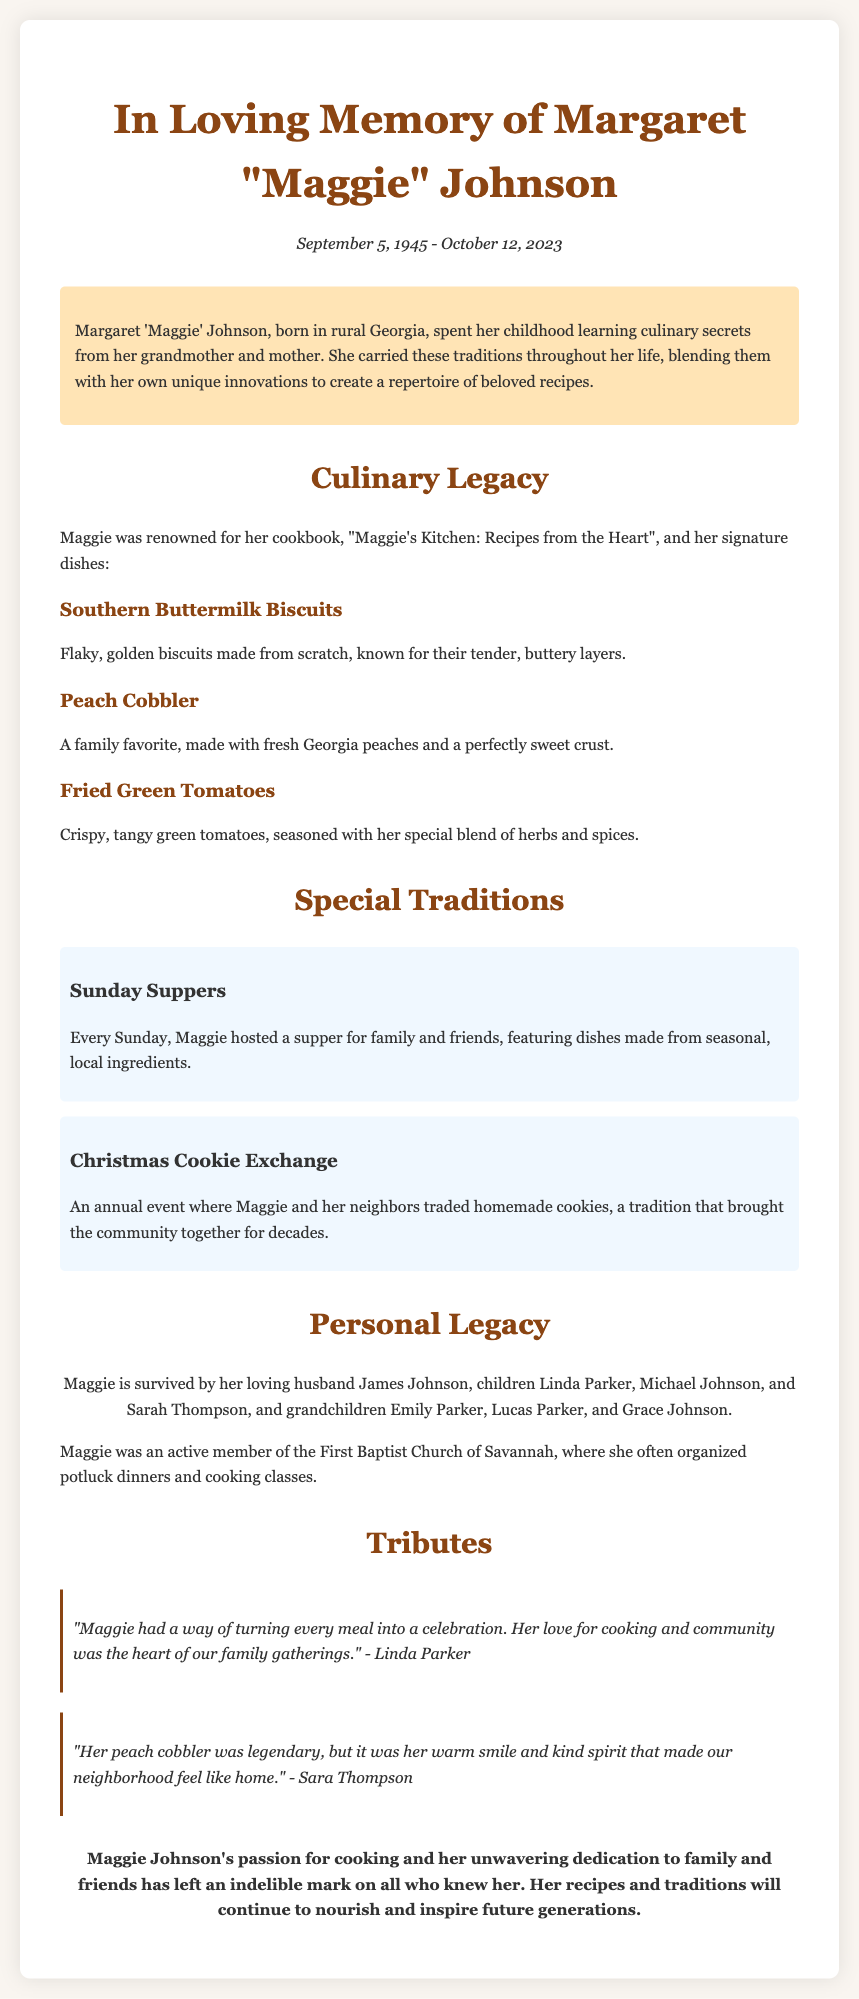What is the full name of the person being commemorated? The document mentions "Margaret 'Maggie' Johnson" as the person being remembered.
Answer: Margaret 'Maggie' Johnson What is the date of birth? The document states that Maggie was born on September 5, 1945.
Answer: September 5, 1945 What is the title of Maggie's cookbook? The document lists the cookbook as "Maggie's Kitchen: Recipes from the Heart".
Answer: Maggie's Kitchen: Recipes from the Heart What dish is described as a family favorite? The document refers to Peach Cobbler as a family favorite.
Answer: Peach Cobbler How many children did Maggie have? The document names three children: Linda Parker, Michael Johnson, and Sarah Thompson.
Answer: Three What special event did Maggie host every Sunday? The document mentions Sunday Suppers as the special event hosted each week.
Answer: Sunday Suppers What was the name of Maggie's husband? The document refers to her husband as James Johnson.
Answer: James Johnson What community activity was Maggie involved in at the First Baptist Church of Savannah? The document mentions she organized potluck dinners and cooking classes.
Answer: Potluck dinners and cooking classes Who said that Maggie's peach cobbler was legendary? The document attributes this statement to Sara Thompson.
Answer: Sara Thompson 